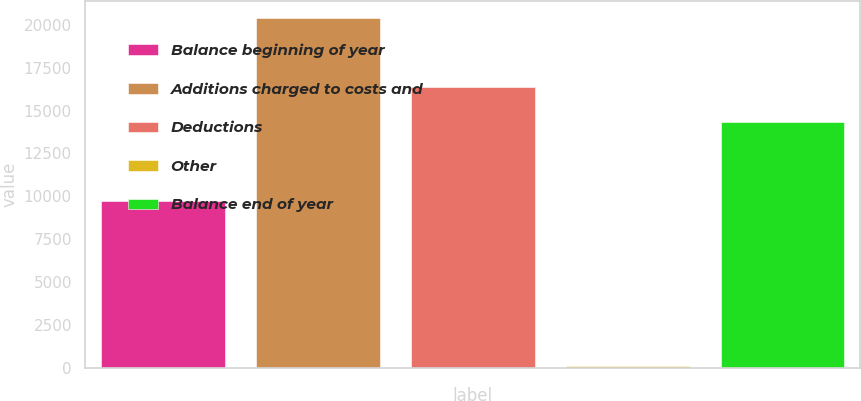<chart> <loc_0><loc_0><loc_500><loc_500><bar_chart><fcel>Balance beginning of year<fcel>Additions charged to costs and<fcel>Deductions<fcel>Other<fcel>Balance end of year<nl><fcel>9755<fcel>20387<fcel>16363.8<fcel>109<fcel>14336<nl></chart> 